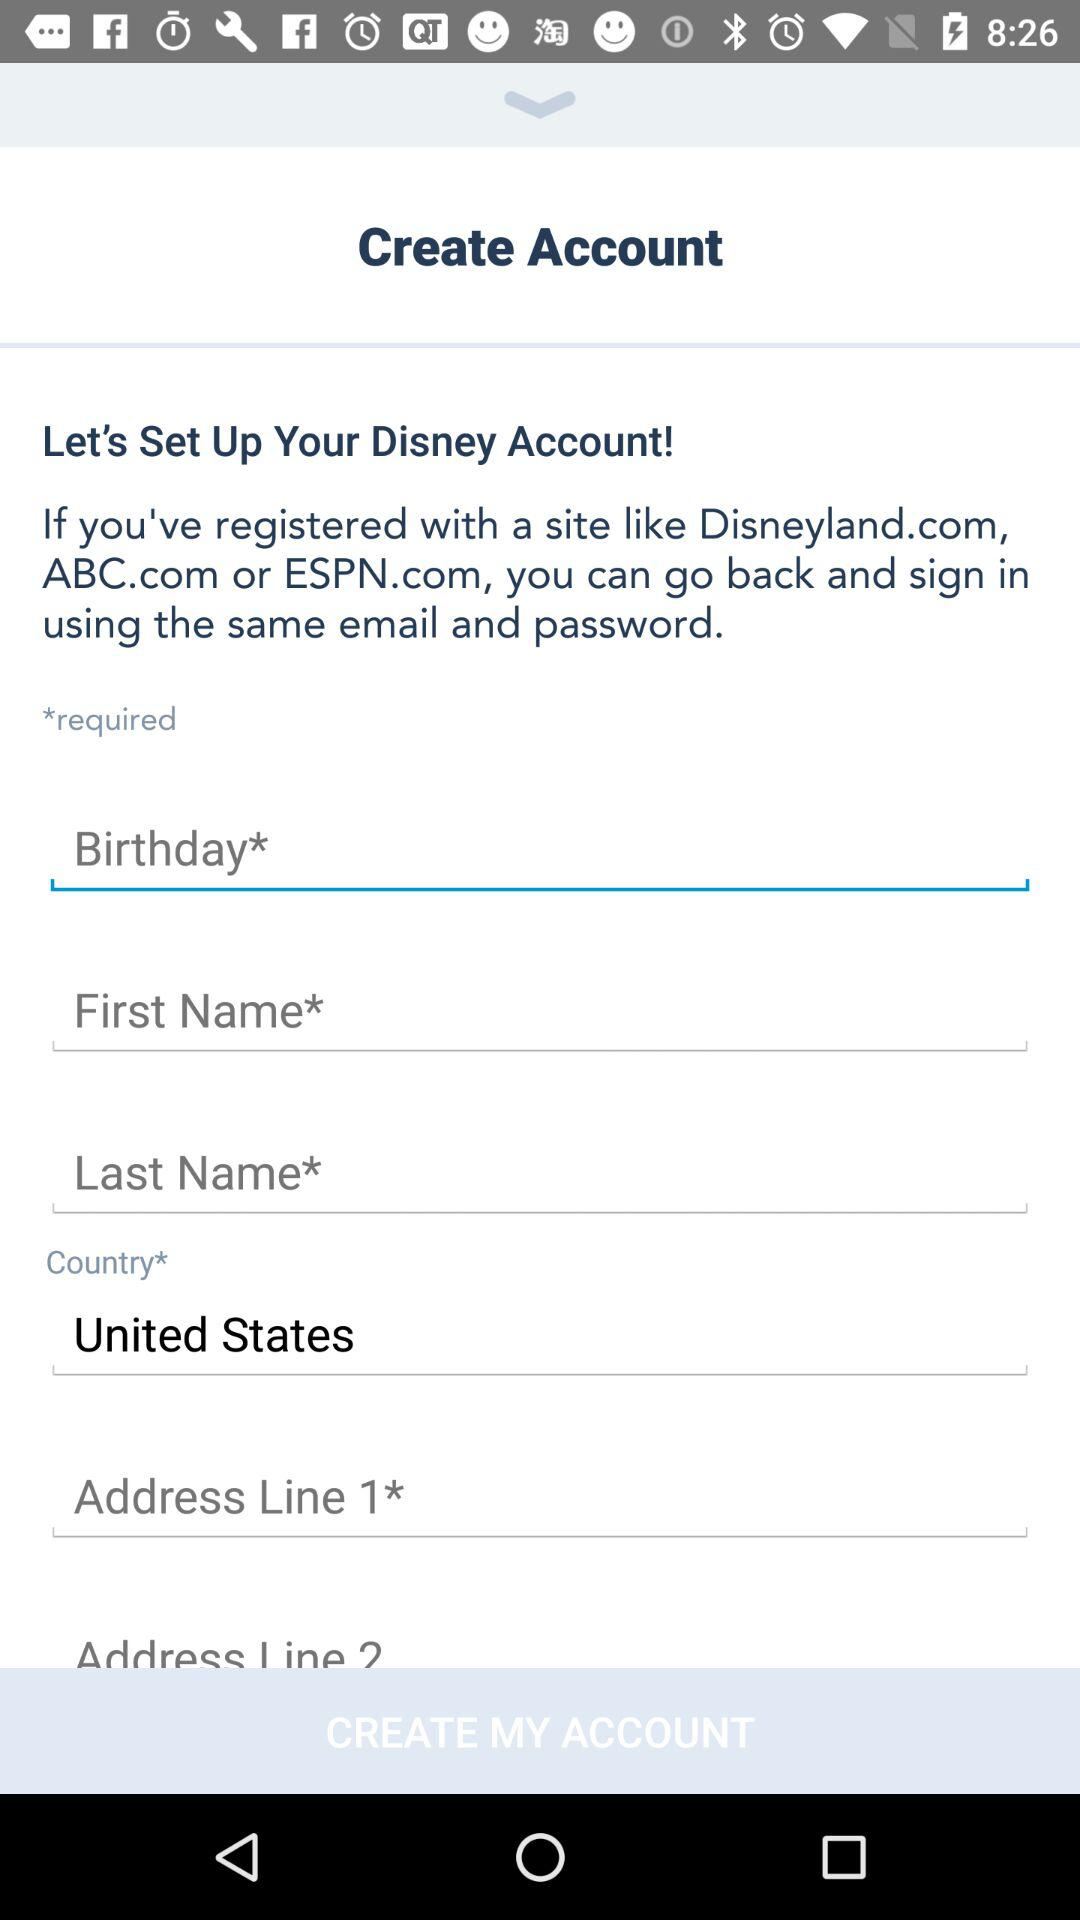Does the form take into account any error handling measures for user input? From the image alone, we cannot determine if there are error handling measures in place. Typically, online forms have checks to ensure information is entered correctly and they might display messages prompting users to correct their data if there are any mistakes. 